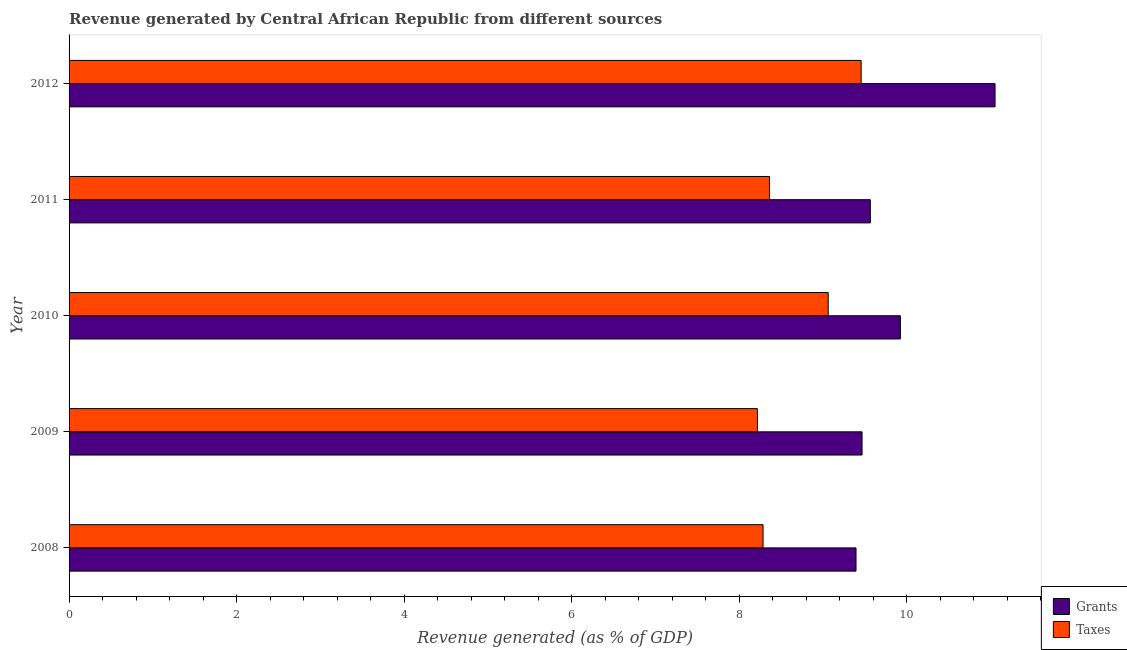How many groups of bars are there?
Make the answer very short. 5. Are the number of bars per tick equal to the number of legend labels?
Offer a very short reply. Yes. Are the number of bars on each tick of the Y-axis equal?
Give a very brief answer. Yes. How many bars are there on the 1st tick from the top?
Provide a short and direct response. 2. How many bars are there on the 1st tick from the bottom?
Your answer should be compact. 2. What is the label of the 2nd group of bars from the top?
Your answer should be very brief. 2011. In how many cases, is the number of bars for a given year not equal to the number of legend labels?
Give a very brief answer. 0. What is the revenue generated by grants in 2011?
Offer a terse response. 9.56. Across all years, what is the maximum revenue generated by grants?
Your answer should be compact. 11.05. Across all years, what is the minimum revenue generated by taxes?
Provide a succinct answer. 8.22. In which year was the revenue generated by taxes minimum?
Offer a terse response. 2009. What is the total revenue generated by grants in the graph?
Your answer should be very brief. 49.4. What is the difference between the revenue generated by taxes in 2009 and that in 2012?
Give a very brief answer. -1.24. What is the difference between the revenue generated by taxes in 2009 and the revenue generated by grants in 2012?
Offer a very short reply. -2.84. What is the average revenue generated by grants per year?
Ensure brevity in your answer.  9.88. In the year 2009, what is the difference between the revenue generated by taxes and revenue generated by grants?
Make the answer very short. -1.25. What is the ratio of the revenue generated by grants in 2009 to that in 2010?
Ensure brevity in your answer.  0.95. Is the difference between the revenue generated by taxes in 2009 and 2011 greater than the difference between the revenue generated by grants in 2009 and 2011?
Your answer should be very brief. No. What is the difference between the highest and the second highest revenue generated by taxes?
Provide a short and direct response. 0.39. What is the difference between the highest and the lowest revenue generated by taxes?
Make the answer very short. 1.24. In how many years, is the revenue generated by taxes greater than the average revenue generated by taxes taken over all years?
Make the answer very short. 2. Is the sum of the revenue generated by grants in 2008 and 2010 greater than the maximum revenue generated by taxes across all years?
Your answer should be very brief. Yes. What does the 1st bar from the top in 2008 represents?
Give a very brief answer. Taxes. What does the 1st bar from the bottom in 2009 represents?
Give a very brief answer. Grants. Are all the bars in the graph horizontal?
Keep it short and to the point. Yes. Are the values on the major ticks of X-axis written in scientific E-notation?
Offer a terse response. No. Does the graph contain any zero values?
Keep it short and to the point. No. Does the graph contain grids?
Your response must be concise. No. How many legend labels are there?
Make the answer very short. 2. How are the legend labels stacked?
Provide a succinct answer. Vertical. What is the title of the graph?
Your response must be concise. Revenue generated by Central African Republic from different sources. Does "International Visitors" appear as one of the legend labels in the graph?
Your response must be concise. No. What is the label or title of the X-axis?
Your answer should be very brief. Revenue generated (as % of GDP). What is the Revenue generated (as % of GDP) of Grants in 2008?
Offer a terse response. 9.39. What is the Revenue generated (as % of GDP) of Taxes in 2008?
Give a very brief answer. 8.28. What is the Revenue generated (as % of GDP) of Grants in 2009?
Your answer should be very brief. 9.47. What is the Revenue generated (as % of GDP) of Taxes in 2009?
Offer a terse response. 8.22. What is the Revenue generated (as % of GDP) in Grants in 2010?
Your answer should be very brief. 9.92. What is the Revenue generated (as % of GDP) in Taxes in 2010?
Offer a very short reply. 9.06. What is the Revenue generated (as % of GDP) of Grants in 2011?
Provide a short and direct response. 9.56. What is the Revenue generated (as % of GDP) of Taxes in 2011?
Your answer should be very brief. 8.36. What is the Revenue generated (as % of GDP) in Grants in 2012?
Ensure brevity in your answer.  11.05. What is the Revenue generated (as % of GDP) of Taxes in 2012?
Keep it short and to the point. 9.46. Across all years, what is the maximum Revenue generated (as % of GDP) in Grants?
Provide a succinct answer. 11.05. Across all years, what is the maximum Revenue generated (as % of GDP) of Taxes?
Offer a terse response. 9.46. Across all years, what is the minimum Revenue generated (as % of GDP) in Grants?
Ensure brevity in your answer.  9.39. Across all years, what is the minimum Revenue generated (as % of GDP) of Taxes?
Keep it short and to the point. 8.22. What is the total Revenue generated (as % of GDP) of Grants in the graph?
Provide a short and direct response. 49.4. What is the total Revenue generated (as % of GDP) in Taxes in the graph?
Your response must be concise. 43.38. What is the difference between the Revenue generated (as % of GDP) in Grants in 2008 and that in 2009?
Provide a short and direct response. -0.07. What is the difference between the Revenue generated (as % of GDP) of Taxes in 2008 and that in 2009?
Keep it short and to the point. 0.07. What is the difference between the Revenue generated (as % of GDP) in Grants in 2008 and that in 2010?
Provide a short and direct response. -0.53. What is the difference between the Revenue generated (as % of GDP) in Taxes in 2008 and that in 2010?
Keep it short and to the point. -0.78. What is the difference between the Revenue generated (as % of GDP) of Grants in 2008 and that in 2011?
Provide a short and direct response. -0.17. What is the difference between the Revenue generated (as % of GDP) in Taxes in 2008 and that in 2011?
Give a very brief answer. -0.08. What is the difference between the Revenue generated (as % of GDP) in Grants in 2008 and that in 2012?
Your answer should be compact. -1.66. What is the difference between the Revenue generated (as % of GDP) of Taxes in 2008 and that in 2012?
Keep it short and to the point. -1.17. What is the difference between the Revenue generated (as % of GDP) of Grants in 2009 and that in 2010?
Offer a terse response. -0.46. What is the difference between the Revenue generated (as % of GDP) in Taxes in 2009 and that in 2010?
Give a very brief answer. -0.84. What is the difference between the Revenue generated (as % of GDP) of Grants in 2009 and that in 2011?
Offer a very short reply. -0.1. What is the difference between the Revenue generated (as % of GDP) in Taxes in 2009 and that in 2011?
Make the answer very short. -0.14. What is the difference between the Revenue generated (as % of GDP) in Grants in 2009 and that in 2012?
Provide a short and direct response. -1.59. What is the difference between the Revenue generated (as % of GDP) of Taxes in 2009 and that in 2012?
Your answer should be very brief. -1.24. What is the difference between the Revenue generated (as % of GDP) in Grants in 2010 and that in 2011?
Offer a terse response. 0.36. What is the difference between the Revenue generated (as % of GDP) of Taxes in 2010 and that in 2011?
Provide a short and direct response. 0.7. What is the difference between the Revenue generated (as % of GDP) of Grants in 2010 and that in 2012?
Provide a short and direct response. -1.13. What is the difference between the Revenue generated (as % of GDP) of Taxes in 2010 and that in 2012?
Your response must be concise. -0.39. What is the difference between the Revenue generated (as % of GDP) in Grants in 2011 and that in 2012?
Your response must be concise. -1.49. What is the difference between the Revenue generated (as % of GDP) of Taxes in 2011 and that in 2012?
Your answer should be compact. -1.09. What is the difference between the Revenue generated (as % of GDP) in Grants in 2008 and the Revenue generated (as % of GDP) in Taxes in 2009?
Your answer should be very brief. 1.18. What is the difference between the Revenue generated (as % of GDP) in Grants in 2008 and the Revenue generated (as % of GDP) in Taxes in 2010?
Keep it short and to the point. 0.33. What is the difference between the Revenue generated (as % of GDP) of Grants in 2008 and the Revenue generated (as % of GDP) of Taxes in 2011?
Offer a very short reply. 1.03. What is the difference between the Revenue generated (as % of GDP) in Grants in 2008 and the Revenue generated (as % of GDP) in Taxes in 2012?
Provide a succinct answer. -0.06. What is the difference between the Revenue generated (as % of GDP) of Grants in 2009 and the Revenue generated (as % of GDP) of Taxes in 2010?
Your response must be concise. 0.4. What is the difference between the Revenue generated (as % of GDP) in Grants in 2009 and the Revenue generated (as % of GDP) in Taxes in 2011?
Your response must be concise. 1.1. What is the difference between the Revenue generated (as % of GDP) in Grants in 2009 and the Revenue generated (as % of GDP) in Taxes in 2012?
Provide a succinct answer. 0.01. What is the difference between the Revenue generated (as % of GDP) in Grants in 2010 and the Revenue generated (as % of GDP) in Taxes in 2011?
Your response must be concise. 1.56. What is the difference between the Revenue generated (as % of GDP) of Grants in 2010 and the Revenue generated (as % of GDP) of Taxes in 2012?
Provide a succinct answer. 0.47. What is the difference between the Revenue generated (as % of GDP) of Grants in 2011 and the Revenue generated (as % of GDP) of Taxes in 2012?
Keep it short and to the point. 0.11. What is the average Revenue generated (as % of GDP) in Grants per year?
Keep it short and to the point. 9.88. What is the average Revenue generated (as % of GDP) in Taxes per year?
Make the answer very short. 8.68. In the year 2008, what is the difference between the Revenue generated (as % of GDP) in Grants and Revenue generated (as % of GDP) in Taxes?
Offer a terse response. 1.11. In the year 2009, what is the difference between the Revenue generated (as % of GDP) in Grants and Revenue generated (as % of GDP) in Taxes?
Your response must be concise. 1.25. In the year 2010, what is the difference between the Revenue generated (as % of GDP) of Grants and Revenue generated (as % of GDP) of Taxes?
Your answer should be compact. 0.86. In the year 2011, what is the difference between the Revenue generated (as % of GDP) of Grants and Revenue generated (as % of GDP) of Taxes?
Offer a very short reply. 1.2. In the year 2012, what is the difference between the Revenue generated (as % of GDP) of Grants and Revenue generated (as % of GDP) of Taxes?
Make the answer very short. 1.6. What is the ratio of the Revenue generated (as % of GDP) in Taxes in 2008 to that in 2009?
Your answer should be very brief. 1.01. What is the ratio of the Revenue generated (as % of GDP) of Grants in 2008 to that in 2010?
Keep it short and to the point. 0.95. What is the ratio of the Revenue generated (as % of GDP) in Taxes in 2008 to that in 2010?
Provide a succinct answer. 0.91. What is the ratio of the Revenue generated (as % of GDP) in Grants in 2008 to that in 2011?
Make the answer very short. 0.98. What is the ratio of the Revenue generated (as % of GDP) in Grants in 2008 to that in 2012?
Ensure brevity in your answer.  0.85. What is the ratio of the Revenue generated (as % of GDP) in Taxes in 2008 to that in 2012?
Your answer should be very brief. 0.88. What is the ratio of the Revenue generated (as % of GDP) in Grants in 2009 to that in 2010?
Offer a terse response. 0.95. What is the ratio of the Revenue generated (as % of GDP) in Taxes in 2009 to that in 2010?
Provide a short and direct response. 0.91. What is the ratio of the Revenue generated (as % of GDP) in Taxes in 2009 to that in 2011?
Offer a very short reply. 0.98. What is the ratio of the Revenue generated (as % of GDP) of Grants in 2009 to that in 2012?
Keep it short and to the point. 0.86. What is the ratio of the Revenue generated (as % of GDP) of Taxes in 2009 to that in 2012?
Your answer should be very brief. 0.87. What is the ratio of the Revenue generated (as % of GDP) in Grants in 2010 to that in 2011?
Provide a succinct answer. 1.04. What is the ratio of the Revenue generated (as % of GDP) of Taxes in 2010 to that in 2011?
Offer a terse response. 1.08. What is the ratio of the Revenue generated (as % of GDP) of Grants in 2010 to that in 2012?
Give a very brief answer. 0.9. What is the ratio of the Revenue generated (as % of GDP) in Taxes in 2010 to that in 2012?
Ensure brevity in your answer.  0.96. What is the ratio of the Revenue generated (as % of GDP) of Grants in 2011 to that in 2012?
Your answer should be compact. 0.87. What is the ratio of the Revenue generated (as % of GDP) of Taxes in 2011 to that in 2012?
Your response must be concise. 0.88. What is the difference between the highest and the second highest Revenue generated (as % of GDP) in Grants?
Give a very brief answer. 1.13. What is the difference between the highest and the second highest Revenue generated (as % of GDP) of Taxes?
Offer a very short reply. 0.39. What is the difference between the highest and the lowest Revenue generated (as % of GDP) in Grants?
Give a very brief answer. 1.66. What is the difference between the highest and the lowest Revenue generated (as % of GDP) in Taxes?
Keep it short and to the point. 1.24. 